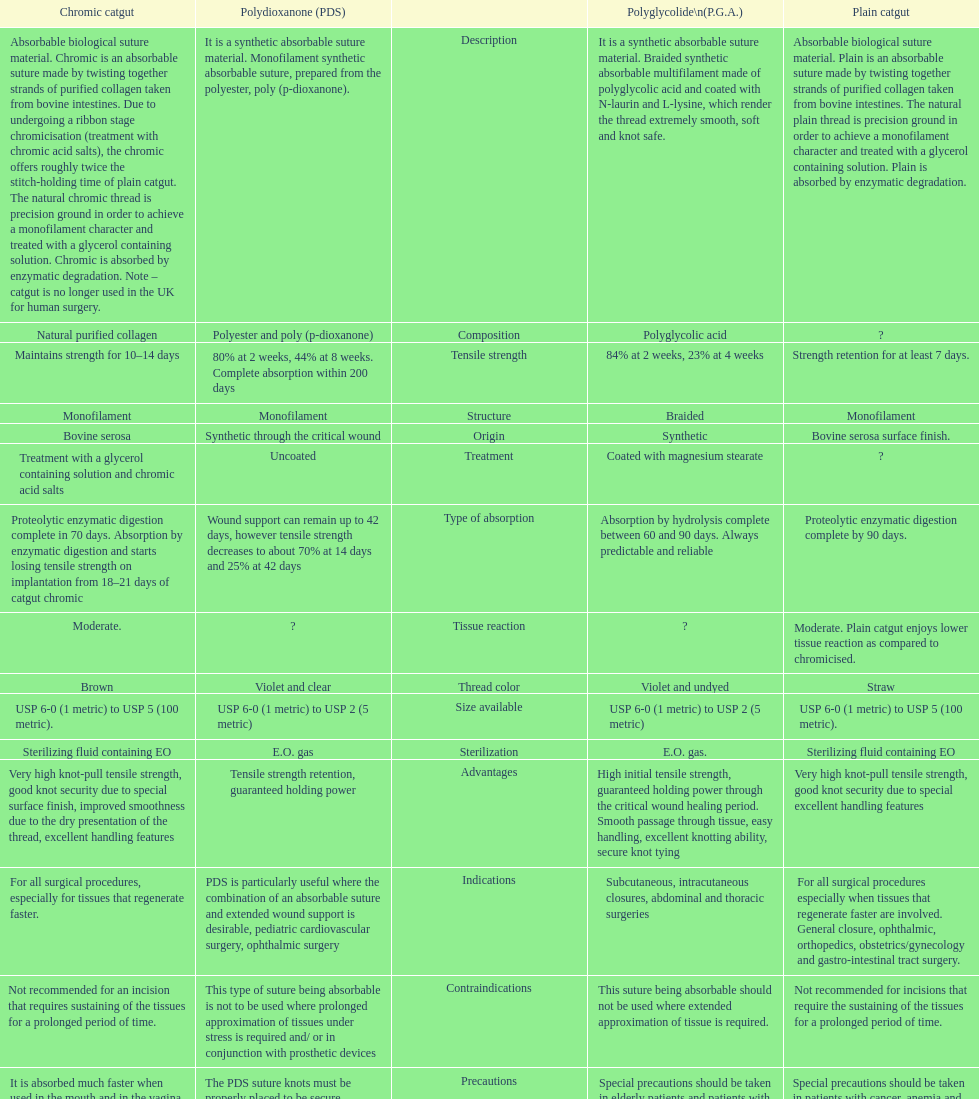What type of suture is not to be used in conjunction with prosthetic devices? Polydioxanone (PDS). 